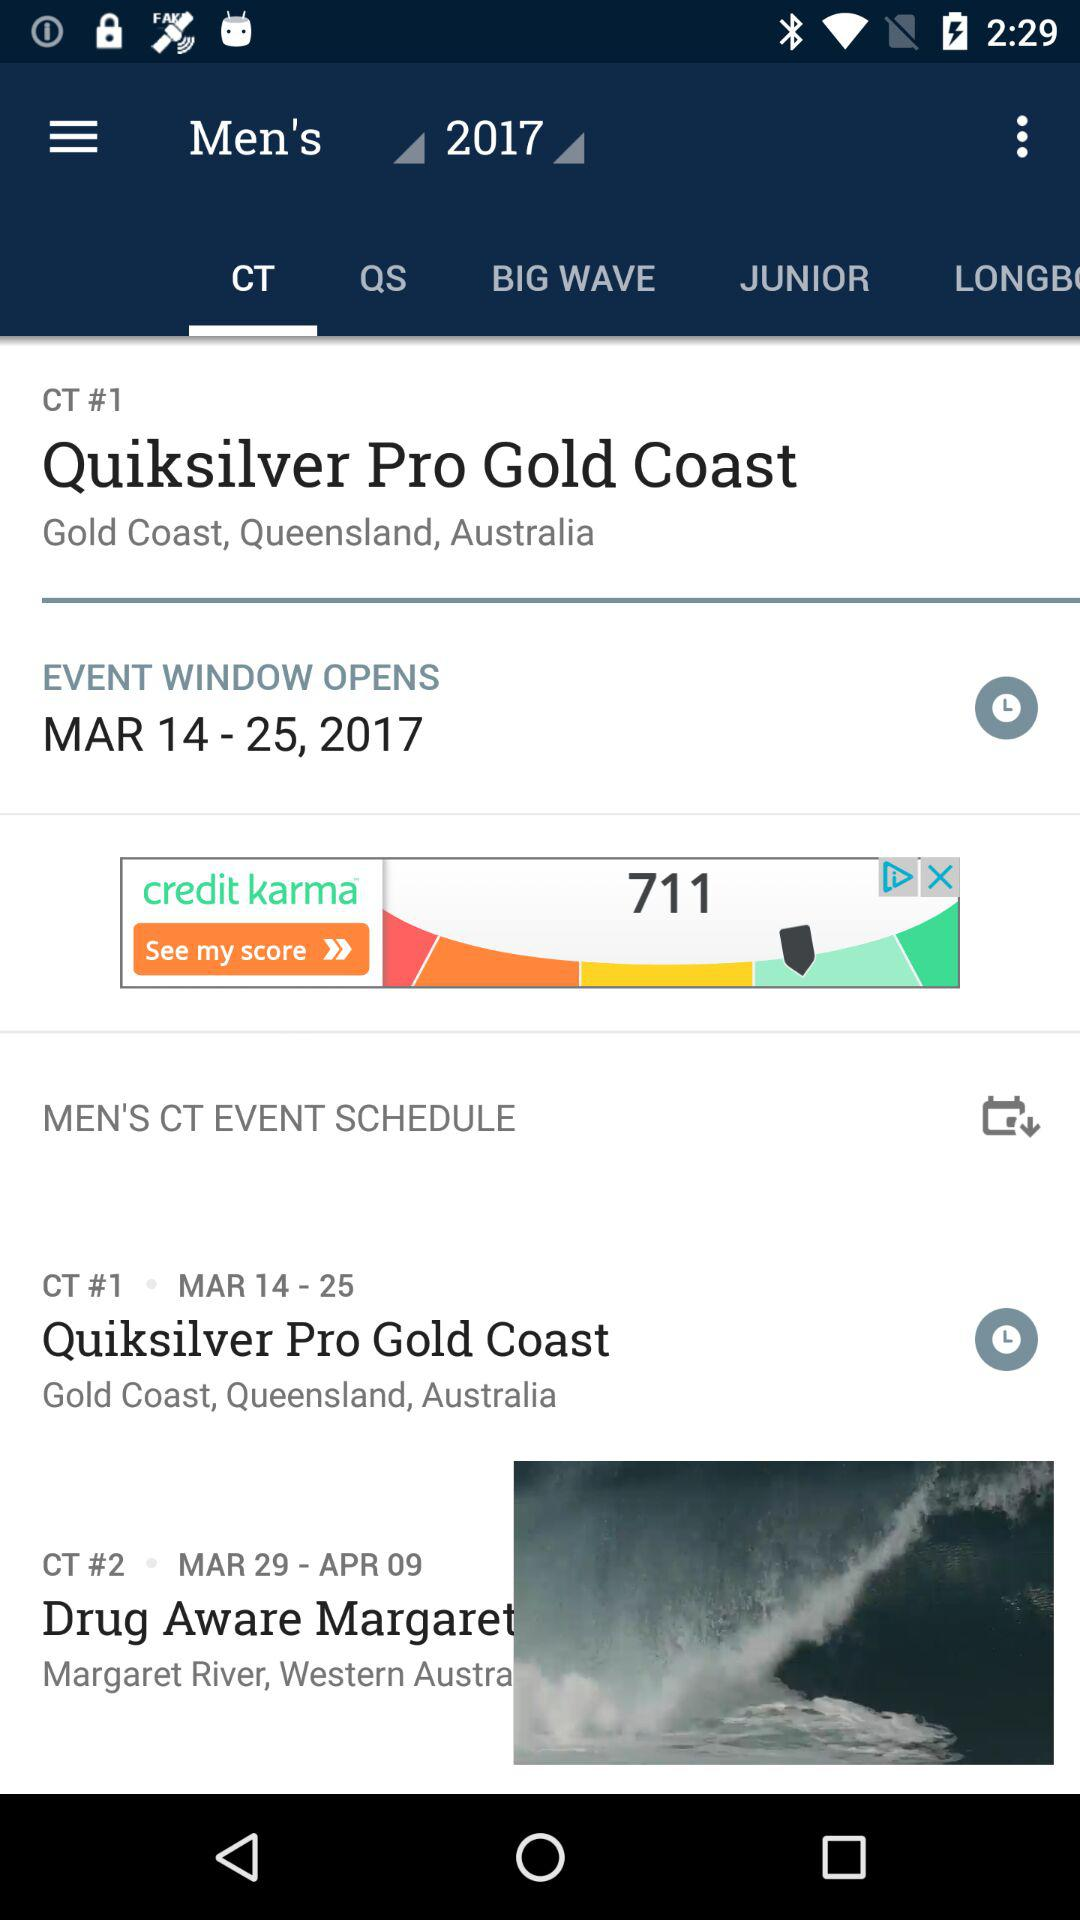How many events are in the CT event schedule?
Answer the question using a single word or phrase. 2 